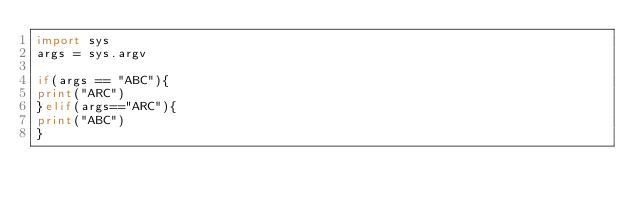<code> <loc_0><loc_0><loc_500><loc_500><_Python_>import sys
args = sys.argv

if(args == "ABC"){
print("ARC")
}elif(args=="ARC"){
print("ABC")
}
</code> 